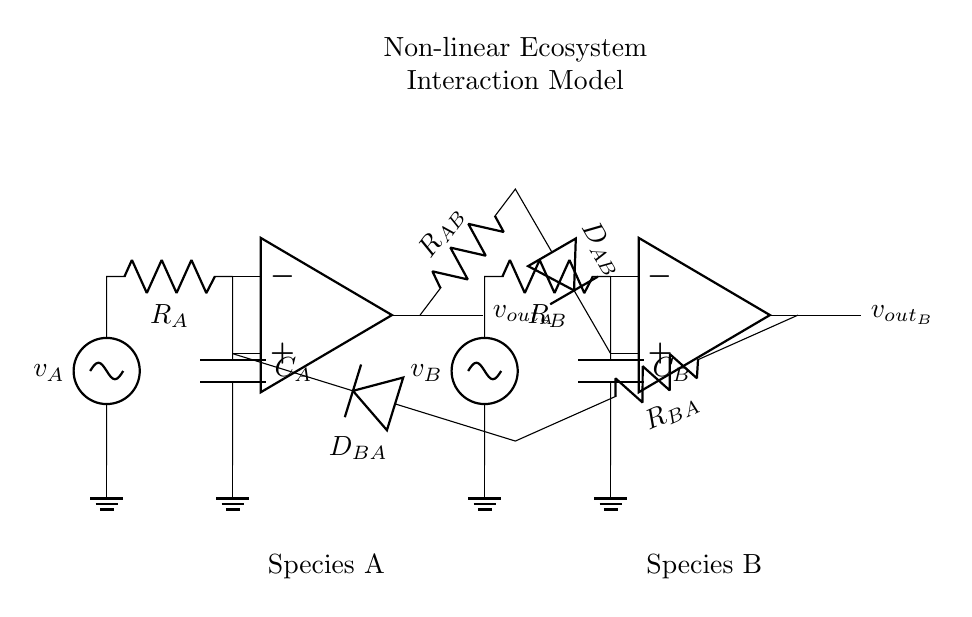What types of components are present in this circuit? The circuit contains operational amplifiers, resistors, capacitors, and diodes. Operational amplifiers are indicated by the op amp symbols. Resistors are labeled as R, capacitors as C, and diodes as D.
Answer: operational amplifiers, resistors, capacitors, diodes What do the diodes represent in this ecosystem model? The diodes likely represent the non-linear interactions between the species A and B, allowing current to flow in one direction, thus modeling the asymmetric interactions.
Answer: non-linear interactions How many operational amplifiers are used in this circuit? There are two operational amplifiers, one for each species A and B, as shown by the two op amp symbols in the circuit diagram.
Answer: two Which component is directly linked to species A's voltage supply? The component directly linked to species A's voltage supply is resistor R_A, which connects the operational amplifier of species A to the voltage source v_A.
Answer: resistor R_A What happens to the output voltage of species A when species B increases? The output voltage of species A will also increase due to the feedback loop created by the connection through the resistor R_{AB} and diode D_{AB}, indicating a positive feedback effect based on species interactions.
Answer: output voltage of species A increases 